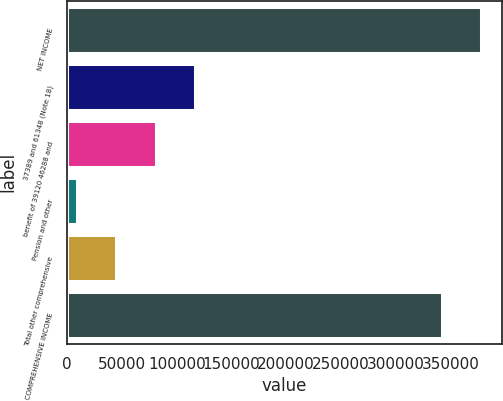Convert chart. <chart><loc_0><loc_0><loc_500><loc_500><bar_chart><fcel>NET INCOME<fcel>37389 and 61348 (Note 18)<fcel>benefit of 39120 46288 and<fcel>Pension and other<fcel>Total other comprehensive<fcel>COMPREHENSIVE INCOME<nl><fcel>378197<fcel>117032<fcel>80864.2<fcel>8528<fcel>44696.1<fcel>342029<nl></chart> 